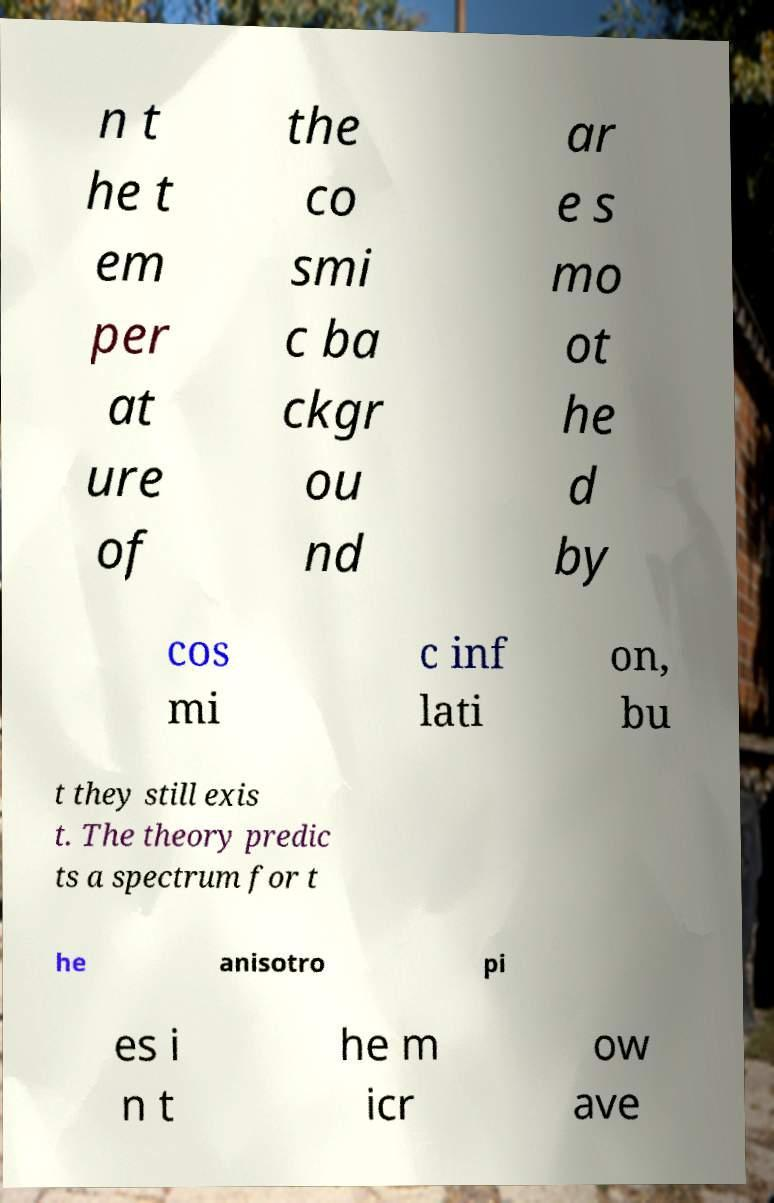Could you assist in decoding the text presented in this image and type it out clearly? n t he t em per at ure of the co smi c ba ckgr ou nd ar e s mo ot he d by cos mi c inf lati on, bu t they still exis t. The theory predic ts a spectrum for t he anisotro pi es i n t he m icr ow ave 